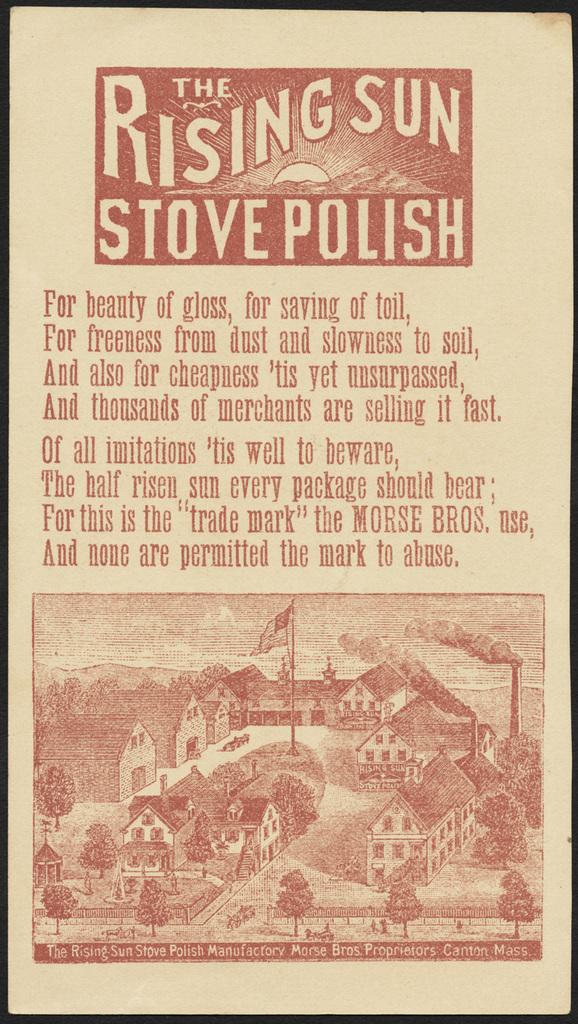<image>
Summarize the visual content of the image. An advertisement features the product The Rising Sun Stove Polish. 